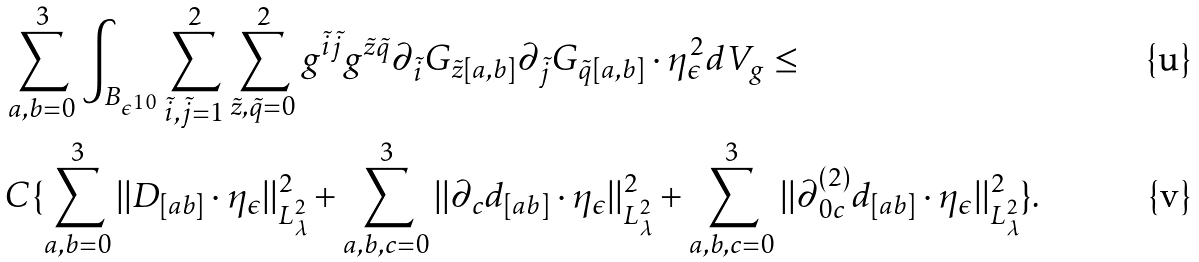Convert formula to latex. <formula><loc_0><loc_0><loc_500><loc_500>& \sum _ { a , b = 0 } ^ { 3 } \int _ { B _ { \epsilon ^ { 1 0 } } } \sum _ { \tilde { i } , \tilde { j } = 1 } ^ { 2 } \sum _ { \tilde { z } , \tilde { q } = 0 } ^ { 2 } g ^ { \tilde { i } \tilde { j } } g ^ { \tilde { z } \tilde { q } } \partial _ { \tilde { i } } G _ { \tilde { z } [ a , b ] } \partial _ { \tilde { j } } G _ { \tilde { q } [ a , b ] } \cdot \eta ^ { 2 } _ { \epsilon } d V _ { g } \leq \\ & C \{ \sum _ { a , b = 0 } ^ { 3 } | | D _ { [ a b ] } \cdot \eta _ { \epsilon } | | ^ { 2 } _ { L ^ { 2 } _ { \lambda } } + \sum _ { a , b , c = 0 } ^ { 3 } | | \partial _ { c } d _ { [ a b ] } \cdot \eta _ { \epsilon } | | ^ { 2 } _ { L ^ { 2 } _ { \lambda } } + \sum _ { a , b , c = 0 } ^ { 3 } | | \partial ^ { ( 2 ) } _ { 0 c } d _ { [ a b ] } \cdot \eta _ { \epsilon } | | ^ { 2 } _ { L ^ { 2 } _ { \lambda } } \} .</formula> 